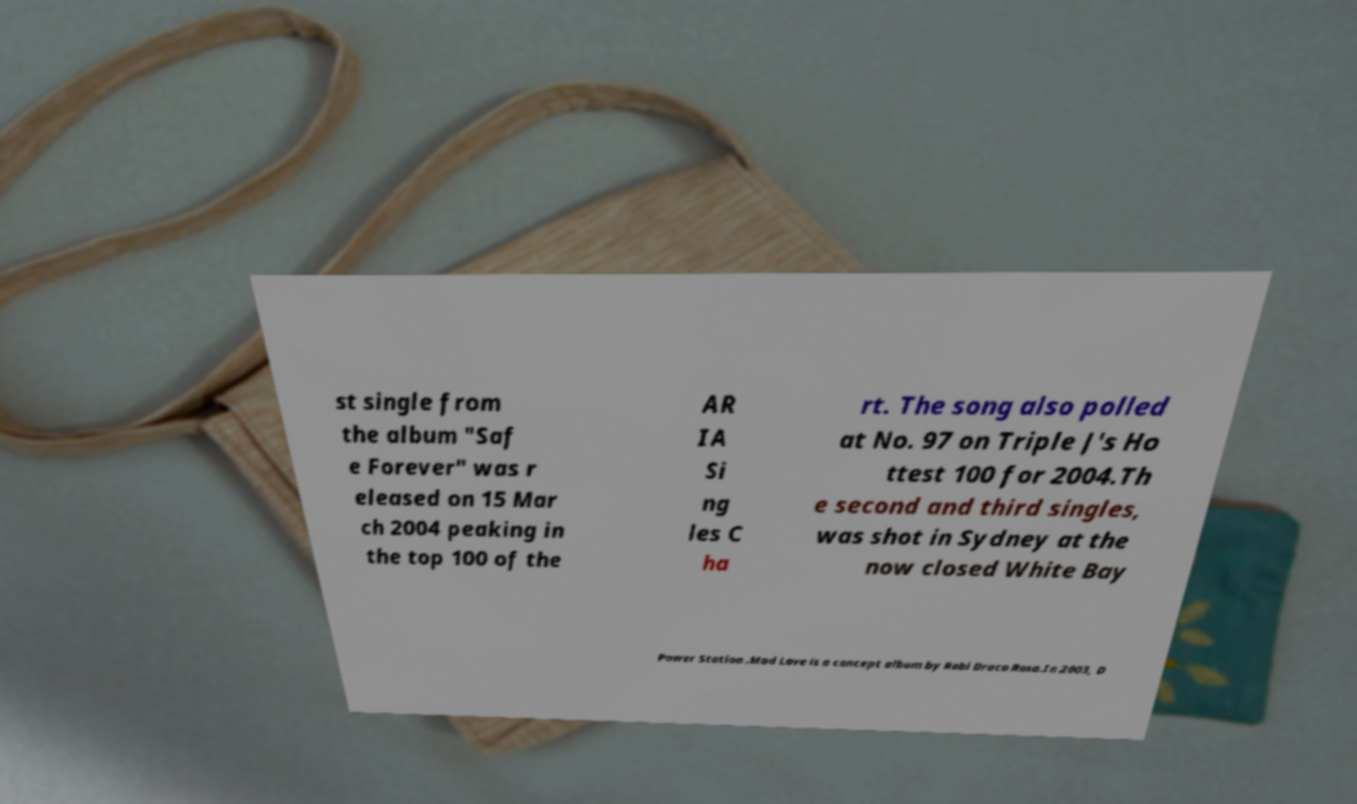Please identify and transcribe the text found in this image. st single from the album "Saf e Forever" was r eleased on 15 Mar ch 2004 peaking in the top 100 of the AR IA Si ng les C ha rt. The song also polled at No. 97 on Triple J's Ho ttest 100 for 2004.Th e second and third singles, was shot in Sydney at the now closed White Bay Power Station .Mad Love is a concept album by Robi Draco Rosa.In 2003, D 